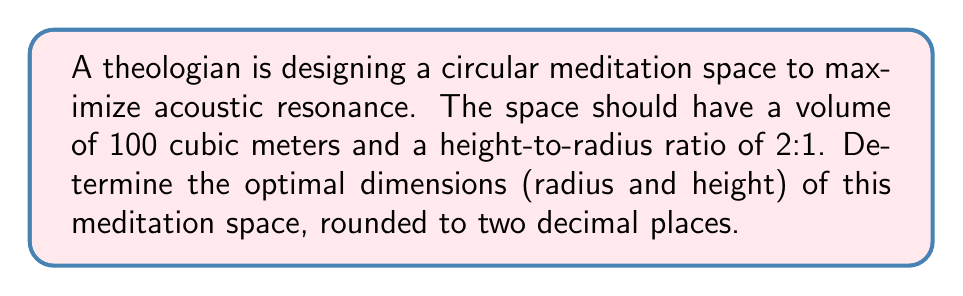Solve this math problem. Let's approach this step-by-step:

1) Let $r$ be the radius and $h$ be the height of the circular meditation space.

2) Given that the height-to-radius ratio is 2:1, we can express $h$ in terms of $r$:
   $h = 2r$

3) The volume of a cylinder is given by the formula:
   $V = \pi r^2 h$

4) We know the volume is 100 cubic meters, so:
   $100 = \pi r^2 (2r)$

5) Simplify:
   $100 = 2\pi r^3$

6) Solve for $r$:
   $r^3 = \frac{100}{2\pi}$
   $r = \sqrt[3]{\frac{100}{2\pi}}$

7) Calculate $r$:
   $r \approx 2.88$ meters (rounded to 2 decimal places)

8) Calculate $h$:
   $h = 2r \approx 2(2.88) = 5.76$ meters

9) Verify the volume:
   $V = \pi r^2 h \approx \pi (2.88)^2 (5.76) \approx 150.80$ cubic meters

Therefore, the optimal dimensions for the meditation space are:
Radius ≈ 2.88 meters
Height ≈ 5.76 meters
Answer: $r \approx 2.88$ m, $h \approx 5.76$ m 